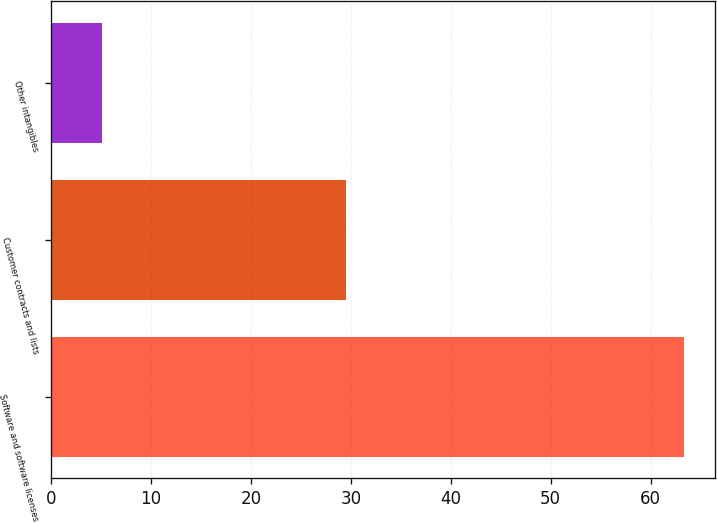<chart> <loc_0><loc_0><loc_500><loc_500><bar_chart><fcel>Software and software licenses<fcel>Customer contracts and lists<fcel>Other intangibles<nl><fcel>63.3<fcel>29.5<fcel>5.1<nl></chart> 